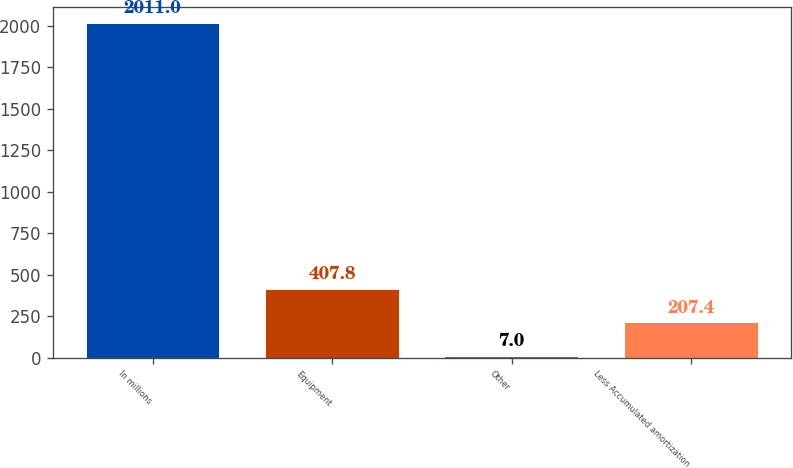Convert chart. <chart><loc_0><loc_0><loc_500><loc_500><bar_chart><fcel>In millions<fcel>Equipment<fcel>Other<fcel>Less Accumulated amortization<nl><fcel>2011<fcel>407.8<fcel>7<fcel>207.4<nl></chart> 